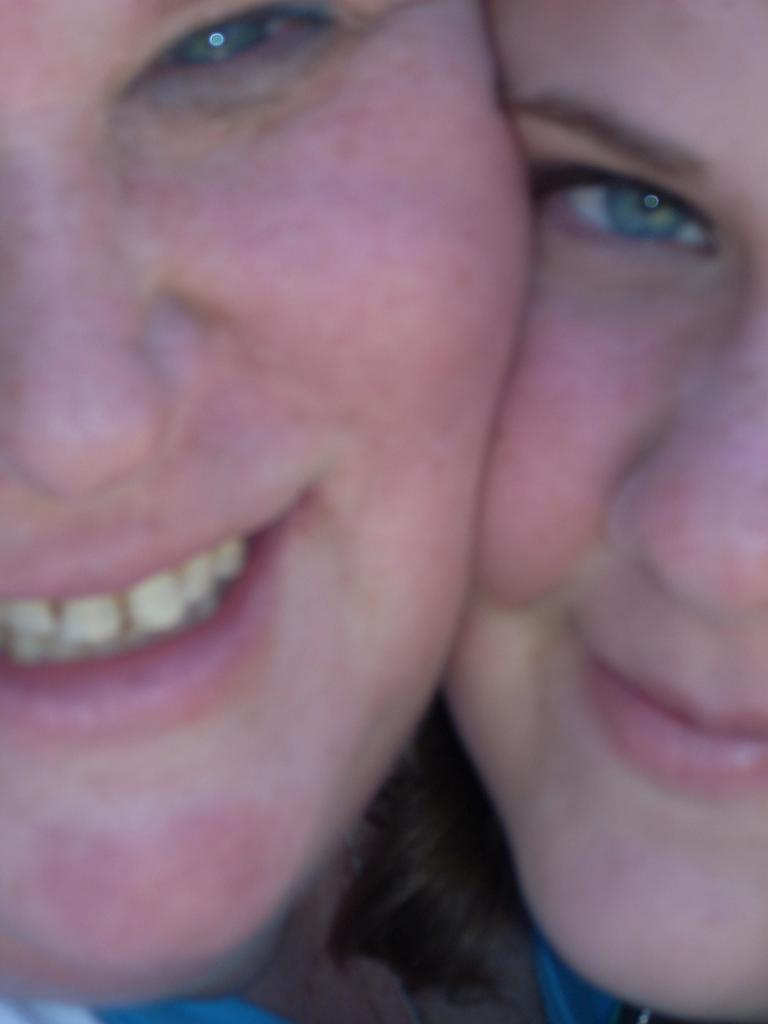How many people are in the image? There are two people in the image. What expressions do the people have in the image? The people are smiling in the image. What type of cap is the uncle wearing in the image? There is no uncle or cap present in the image. Can you tell me how many copies of the image are available? There is no information about the availability of copies of the image. 